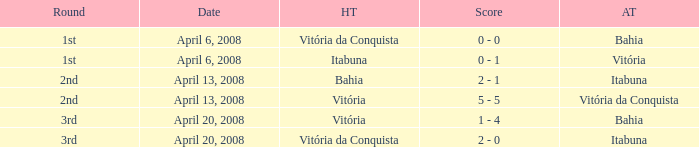On which date was the score 0 - 0? April 6, 2008. 